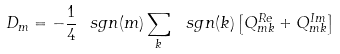<formula> <loc_0><loc_0><loc_500><loc_500>D _ { m } = - \frac { 1 } { 4 } \ s g n ( m ) \sum _ { k } \ s g n ( k ) \left [ Q _ { m k } ^ { R e } + Q _ { m k } ^ { I m } \right ]</formula> 